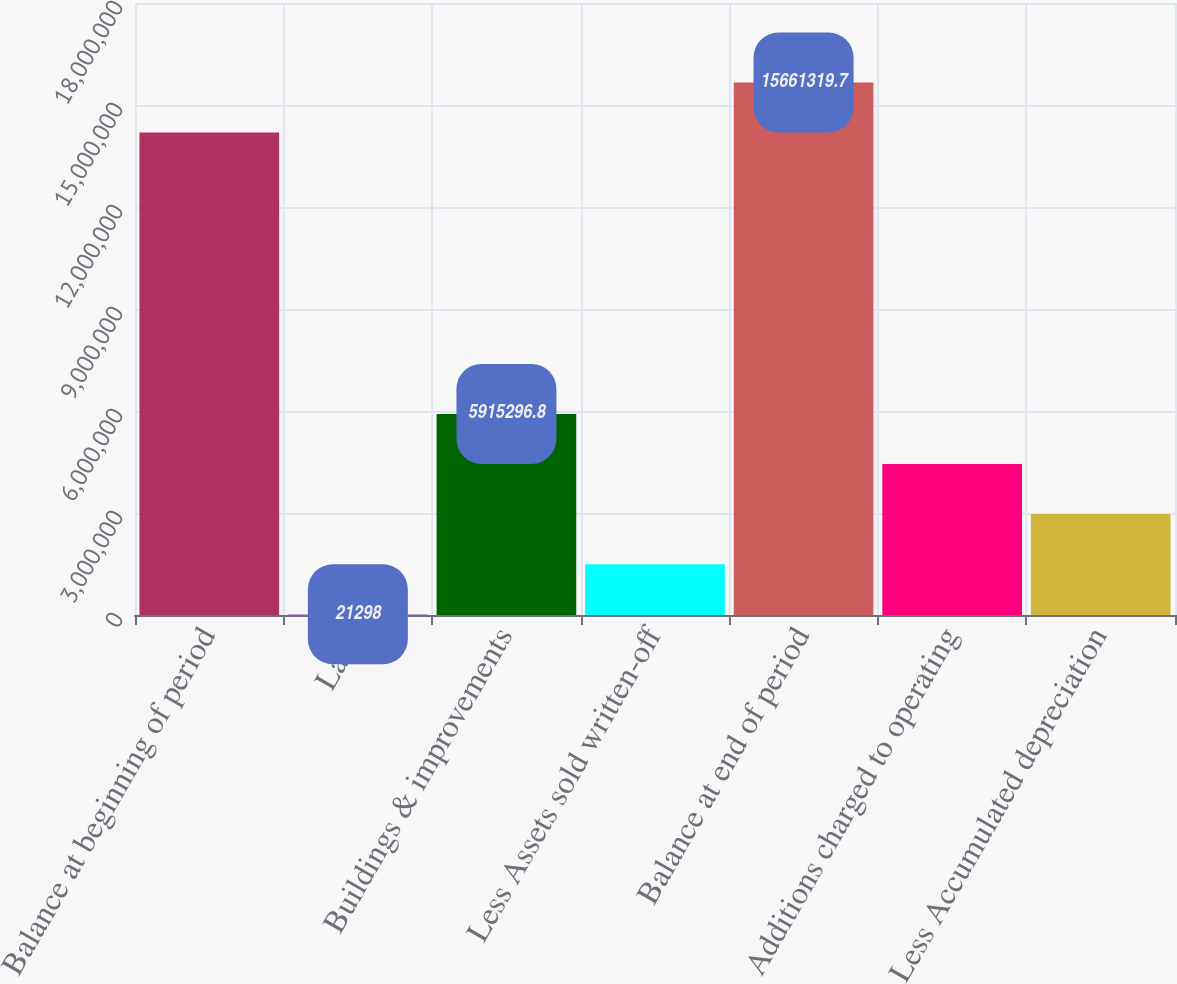<chart> <loc_0><loc_0><loc_500><loc_500><bar_chart><fcel>Balance at beginning of period<fcel>Land<fcel>Buildings & improvements<fcel>Less Assets sold written-off<fcel>Balance at end of period<fcel>Additions charged to operating<fcel>Less Accumulated depreciation<nl><fcel>1.41878e+07<fcel>21298<fcel>5.9153e+06<fcel>1.4948e+06<fcel>1.56613e+07<fcel>4.4418e+06<fcel>2.9683e+06<nl></chart> 